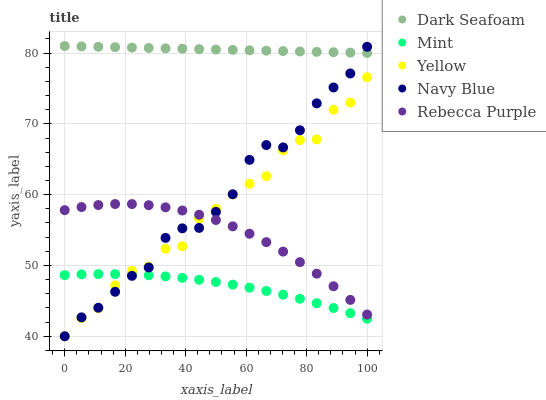Does Mint have the minimum area under the curve?
Answer yes or no. Yes. Does Dark Seafoam have the maximum area under the curve?
Answer yes or no. Yes. Does Dark Seafoam have the minimum area under the curve?
Answer yes or no. No. Does Mint have the maximum area under the curve?
Answer yes or no. No. Is Dark Seafoam the smoothest?
Answer yes or no. Yes. Is Yellow the roughest?
Answer yes or no. Yes. Is Mint the smoothest?
Answer yes or no. No. Is Mint the roughest?
Answer yes or no. No. Does Navy Blue have the lowest value?
Answer yes or no. Yes. Does Mint have the lowest value?
Answer yes or no. No. Does Dark Seafoam have the highest value?
Answer yes or no. Yes. Does Mint have the highest value?
Answer yes or no. No. Is Mint less than Dark Seafoam?
Answer yes or no. Yes. Is Dark Seafoam greater than Mint?
Answer yes or no. Yes. Does Navy Blue intersect Dark Seafoam?
Answer yes or no. Yes. Is Navy Blue less than Dark Seafoam?
Answer yes or no. No. Is Navy Blue greater than Dark Seafoam?
Answer yes or no. No. Does Mint intersect Dark Seafoam?
Answer yes or no. No. 